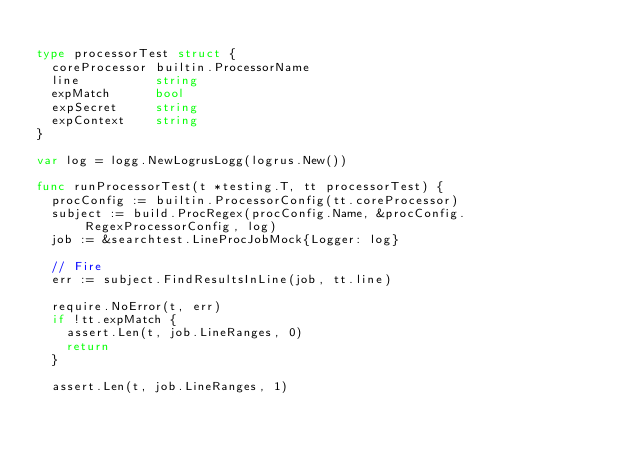Convert code to text. <code><loc_0><loc_0><loc_500><loc_500><_Go_>
type processorTest struct {
	coreProcessor builtin.ProcessorName
	line          string
	expMatch      bool
	expSecret     string
	expContext    string
}

var log = logg.NewLogrusLogg(logrus.New())

func runProcessorTest(t *testing.T, tt processorTest) {
	procConfig := builtin.ProcessorConfig(tt.coreProcessor)
	subject := build.ProcRegex(procConfig.Name, &procConfig.RegexProcessorConfig, log)
	job := &searchtest.LineProcJobMock{Logger: log}

	// Fire
	err := subject.FindResultsInLine(job, tt.line)

	require.NoError(t, err)
	if !tt.expMatch {
		assert.Len(t, job.LineRanges, 0)
		return
	}

	assert.Len(t, job.LineRanges, 1)</code> 